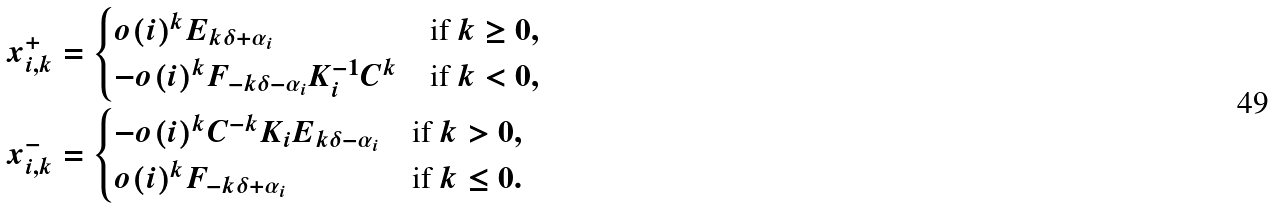Convert formula to latex. <formula><loc_0><loc_0><loc_500><loc_500>x _ { i , k } ^ { + } & = \begin{cases} o ( i ) ^ { k } E _ { k \delta + \alpha _ { i } } & \text {if $k\geq 0$} , \\ - o ( i ) ^ { k } F _ { - k \delta - \alpha _ { i } } K _ { i } ^ { - 1 } C ^ { k } & \text {if   $k<0$} , \end{cases} \\ x _ { i , k } ^ { - } & = \begin{cases} - o ( i ) ^ { k } C ^ { - k } K _ { i } E _ { k \delta - \alpha _ { i } } & \text {if    $k> 0$} , \\ o ( i ) ^ { k } F _ { - k \delta + \alpha _ { i } } & \text {if $k\leq    0$} . \end{cases}</formula> 